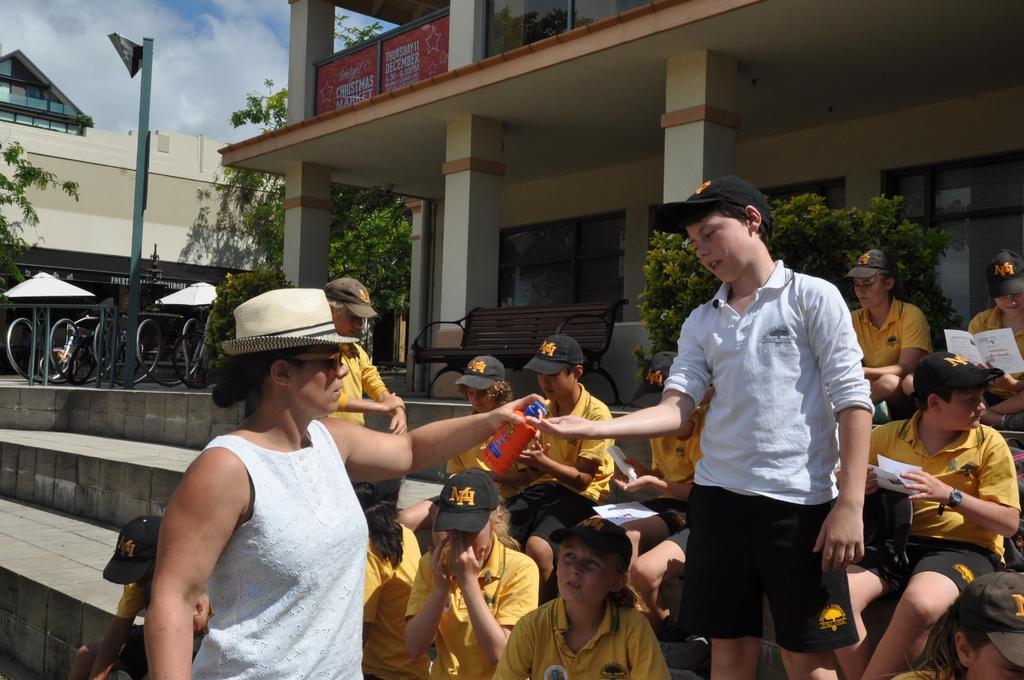Can you describe this image briefly? On the right side of the image there are a few people sitting and two are standing on the stairs of a building, In front of the building there is a bench, on either side of the bench there are trees and plants. On the left side of the image there is a railing, beside that there is a poll. In the background there is another building and sky. 